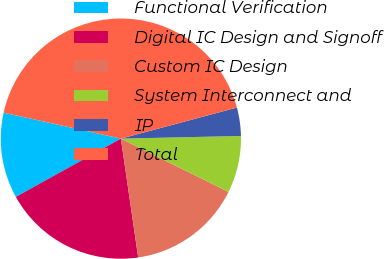<chart> <loc_0><loc_0><loc_500><loc_500><pie_chart><fcel>Functional Verification<fcel>Digital IC Design and Signoff<fcel>Custom IC Design<fcel>System Interconnect and<fcel>IP<fcel>Total<nl><fcel>11.53%<fcel>19.24%<fcel>15.38%<fcel>7.67%<fcel>3.81%<fcel>42.37%<nl></chart> 